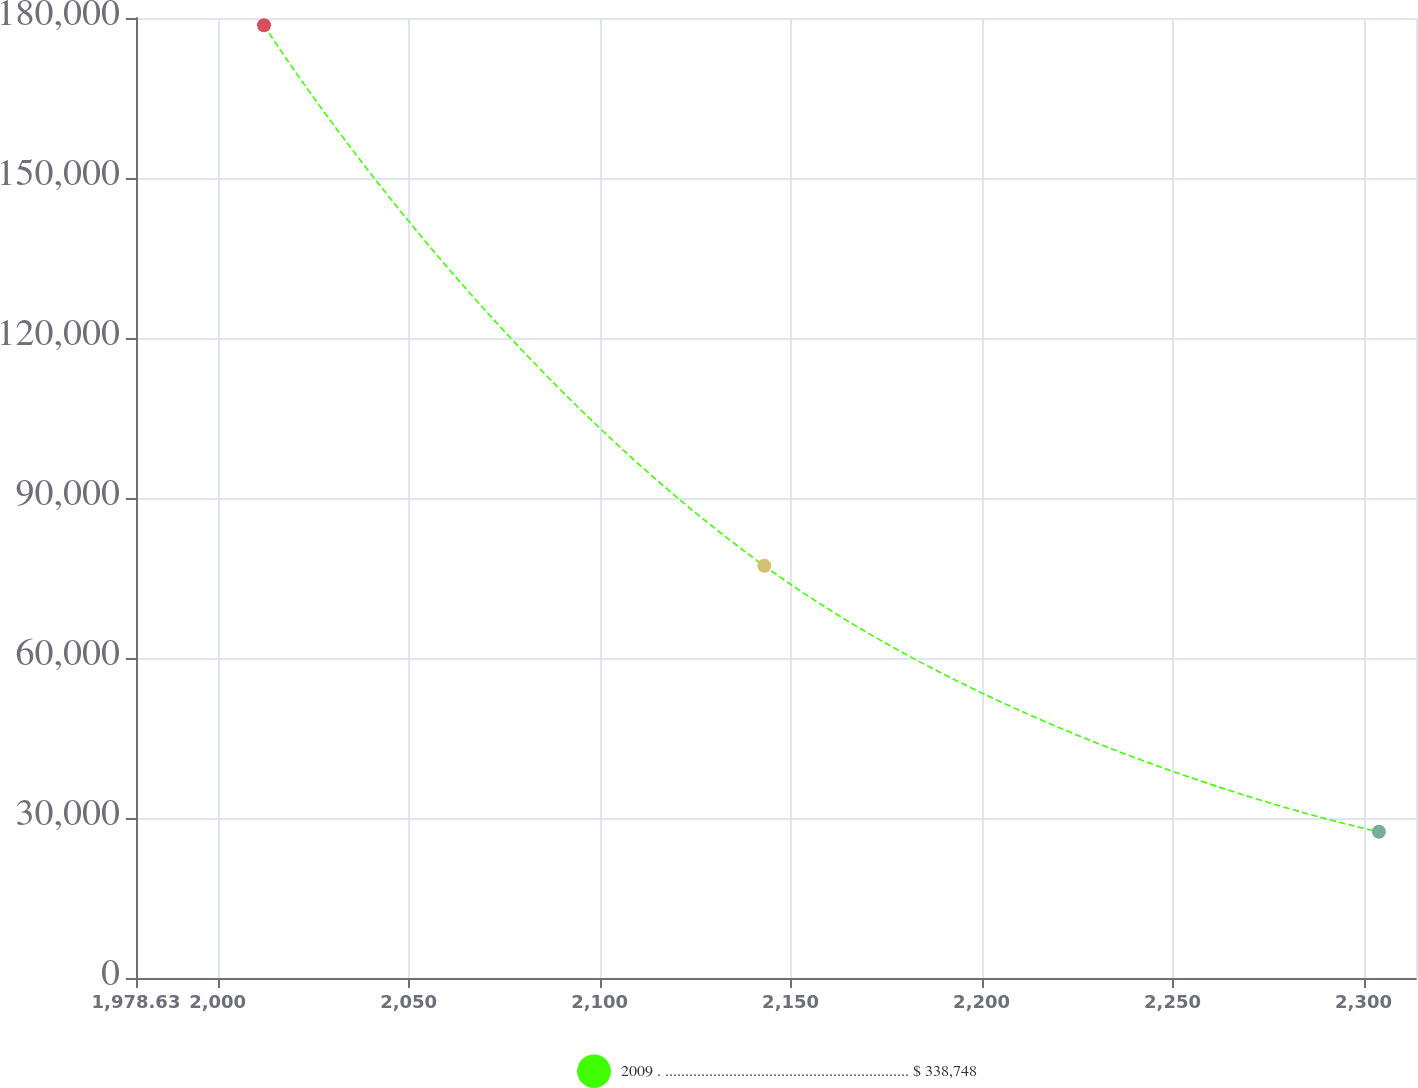<chart> <loc_0><loc_0><loc_500><loc_500><line_chart><ecel><fcel>2009 . ............................................................. $ 338,748<nl><fcel>2012.14<fcel>178647<nl><fcel>2143.12<fcel>77281.4<nl><fcel>2304.02<fcel>27416.8<nl><fcel>2347.24<fcel>3535<nl></chart> 